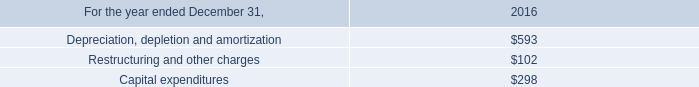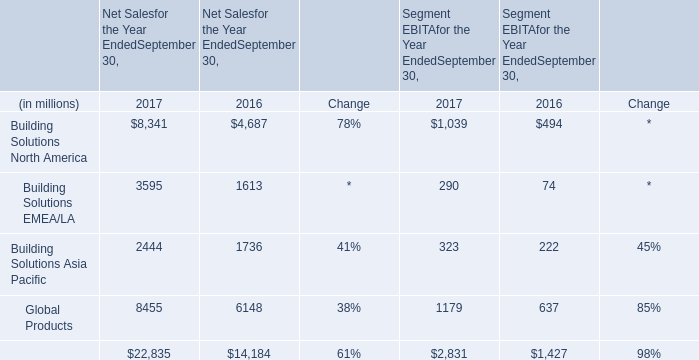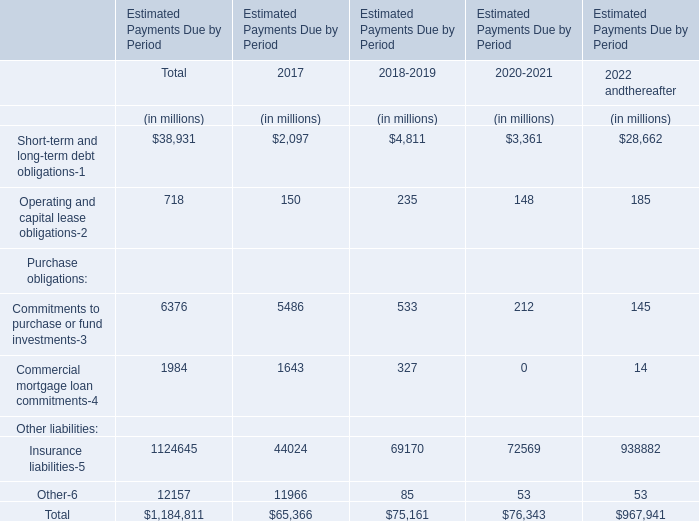how bigger are the expenses with depreciation depletion and amortization as a percent of capital expenditures in 2016? 
Computations: ((593 / 298) - 1)
Answer: 0.98993. 